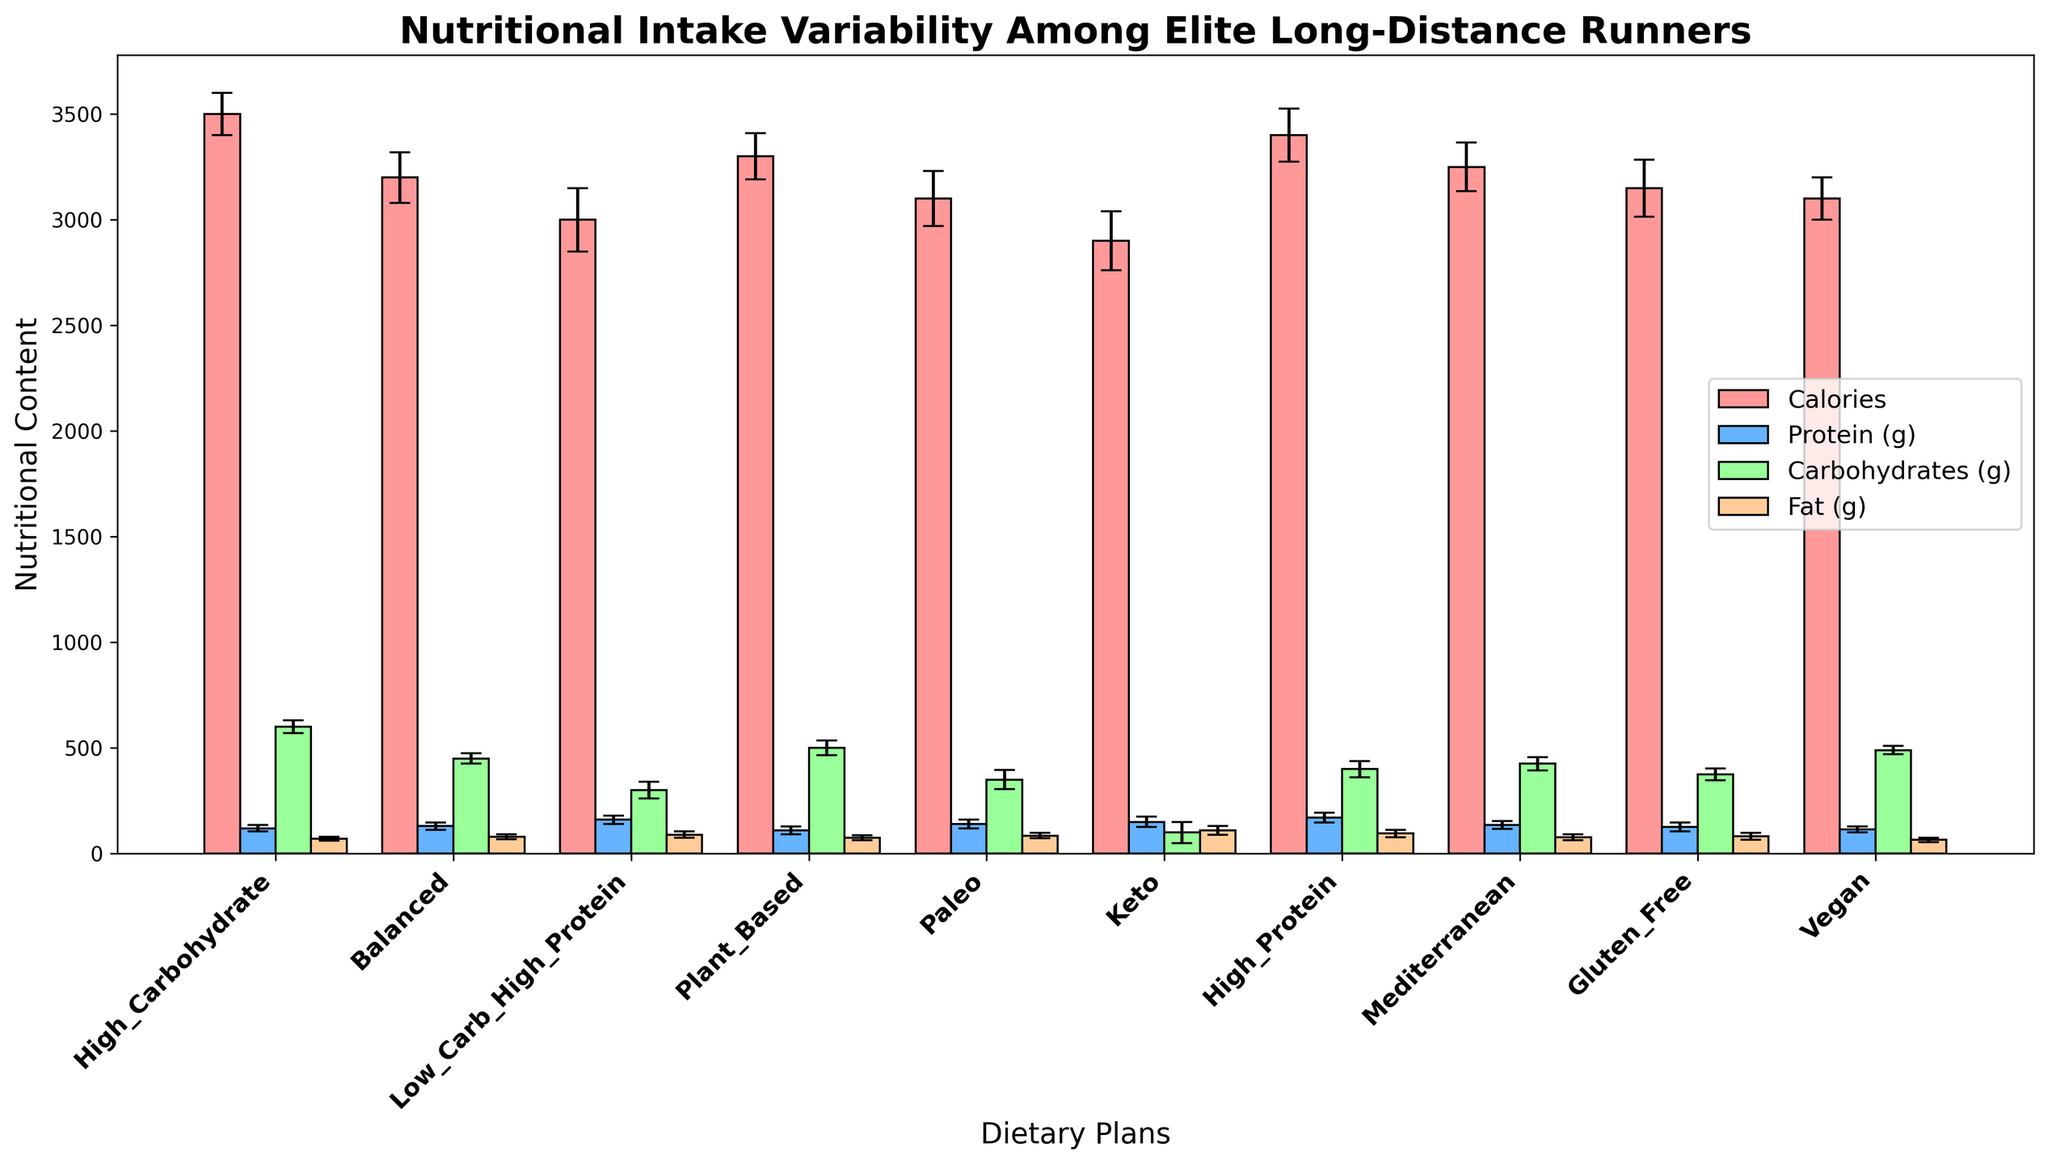Which dietary plan has the highest average protein intake? Look at the height of the blue bars, which represent average protein intake. The highest blue bar corresponds to the "High_Protein" dietary plan.
Answer: High_Protein What is the difference in average calories between the High_Carbohydrate and Keto dietary plans? Observe the red bars' height for the High_Carbohydrate and Keto categories. High_Carbohydrate has 3500, and Keto has 2900. The difference is 3500 - 2900.
Answer: 600 Which dietary plan shows the smallest variability in fat intake? Look at the error bars (capsize lines) on the orange bars representing fat intake. The dietary plan with the smallest error bar is "Vegan."
Answer: Vegan Among all dietary plans, which one has the least average carbohydrate intake? Inspect the green bars representing carbohydrates' average. The lowest green bar is for the "Keto" dietary plan.
Answer: Keto Between Balanced and Paleo diets, which one has a higher average protein intake and by how much? Compare the height of the blue bars for the Balanced and Paleo diets. Balanced has 130g, while Paleo has 140g. The difference is 140 - 130.
Answer: Paleo by 10g What is the average carbohydrate intake for Plant_Based and Balanced dietary plans combined? The values for Plant_Based and Balanced are 500g and 450g, respectively. Add them and divide by 2: (500 + 450) / 2.
Answer: 475g Does the Mediterranean diet have a higher or lower average fat intake compared to the Gluten_Free diet, and by how much? Compare the heights of the orange bars for the Mediterranean (78g) and Gluten_Free (82g) diets. The difference is 82 - 78.
Answer: Lower by 4g Which dietary plan has the highest standard deviation in carbohydrate intake? Look for the green error bars with the largest height. The "Keto" dietary plan has the highest standard deviation at 50.
Answer: Keto Which dietary plans have an average caloric intake greater than 3200 calories? Check the red bars higher than the 3200 mark. These are High_Carbohydrate, Balanced, Plant_Based, High_Protein, and Mediterranean.
Answer: High_Carbohydrate, Balanced, Plant_Based, High_Protein, Mediterranean Is the average protein intake of the Vegan diet lower than that of the Plant_Based diet, and if so, by how much? Compare the blue bars for Vegan and Plant_Based diets. Vegan has 115g, and Plant_Based has 110g. The difference is 115 - 110.
Answer: No, Vegan is higher by 5g 